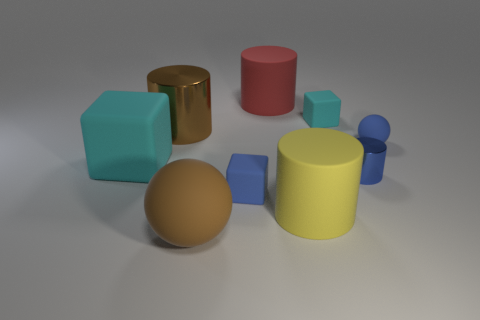What number of large things are cyan matte blocks or red rubber cylinders?
Offer a very short reply. 2. Is there another big yellow metal object that has the same shape as the big shiny thing?
Provide a short and direct response. No. Do the small metallic thing and the yellow thing have the same shape?
Keep it short and to the point. Yes. The large rubber cylinder that is in front of the large matte object on the left side of the brown rubber thing is what color?
Your response must be concise. Yellow. There is a rubber cube that is the same size as the yellow matte cylinder; what color is it?
Your response must be concise. Cyan. How many rubber things are large red cylinders or large cylinders?
Keep it short and to the point. 2. There is a large cyan thing that is left of the big brown rubber object; what number of large brown things are behind it?
Ensure brevity in your answer.  1. There is a sphere that is the same color as the big shiny object; what is its size?
Ensure brevity in your answer.  Large. How many things are either cylinders or metallic cylinders behind the blue matte sphere?
Keep it short and to the point. 4. Is there a brown object that has the same material as the blue sphere?
Offer a terse response. Yes. 